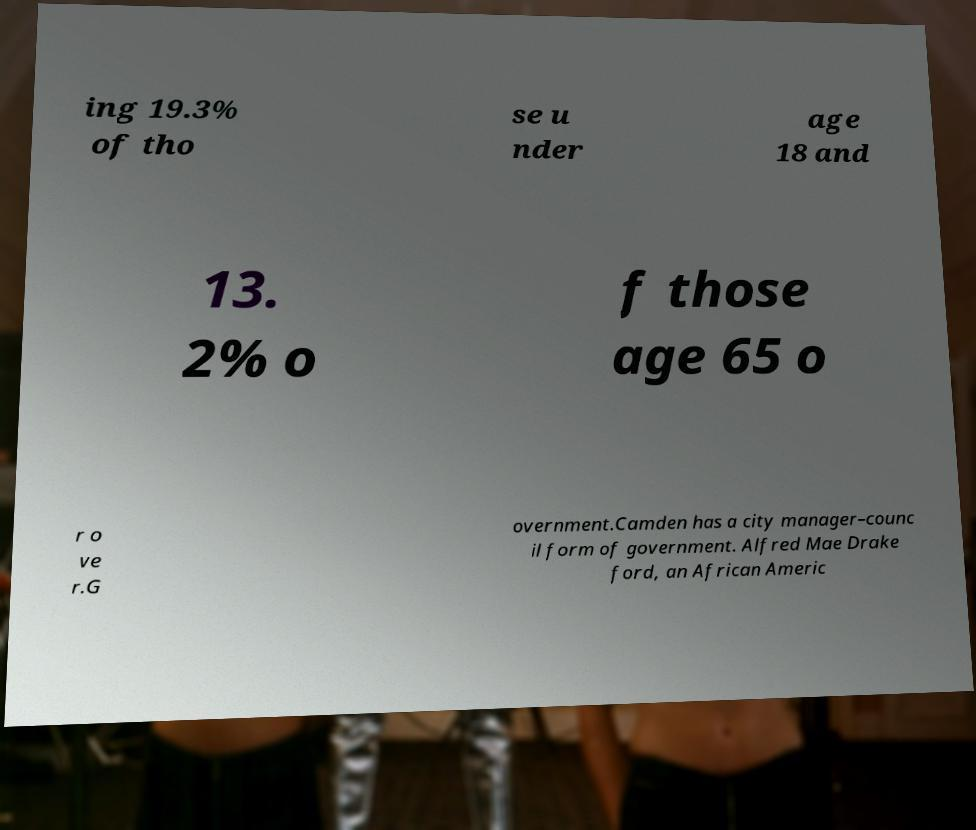For documentation purposes, I need the text within this image transcribed. Could you provide that? ing 19.3% of tho se u nder age 18 and 13. 2% o f those age 65 o r o ve r.G overnment.Camden has a city manager–counc il form of government. Alfred Mae Drake ford, an African Americ 